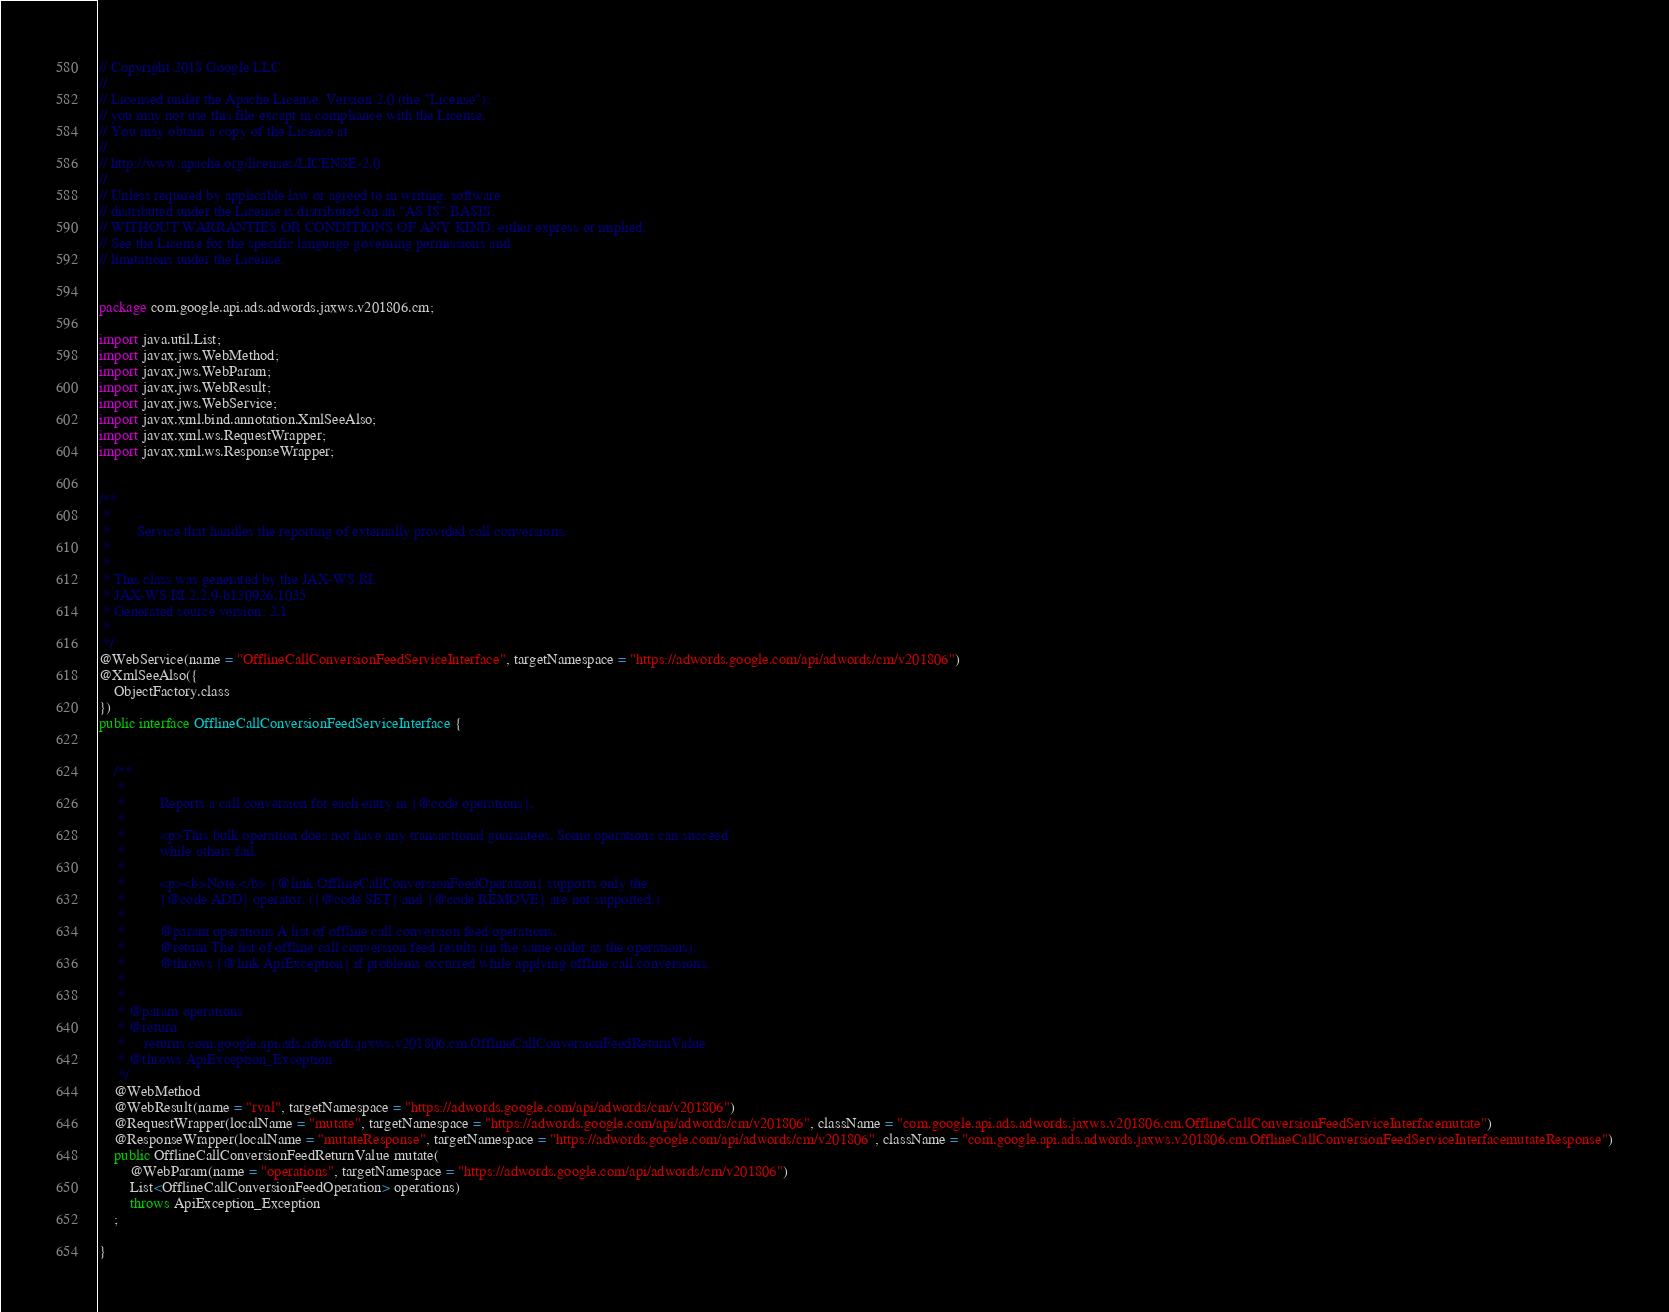<code> <loc_0><loc_0><loc_500><loc_500><_Java_>// Copyright 2018 Google LLC
//
// Licensed under the Apache License, Version 2.0 (the "License");
// you may not use this file except in compliance with the License.
// You may obtain a copy of the License at
//
// http://www.apache.org/licenses/LICENSE-2.0
//
// Unless required by applicable law or agreed to in writing, software
// distributed under the License is distributed on an "AS IS" BASIS,
// WITHOUT WARRANTIES OR CONDITIONS OF ANY KIND, either express or implied.
// See the License for the specific language governing permissions and
// limitations under the License.


package com.google.api.ads.adwords.jaxws.v201806.cm;

import java.util.List;
import javax.jws.WebMethod;
import javax.jws.WebParam;
import javax.jws.WebResult;
import javax.jws.WebService;
import javax.xml.bind.annotation.XmlSeeAlso;
import javax.xml.ws.RequestWrapper;
import javax.xml.ws.ResponseWrapper;


/**
 * 
 *       Service that handles the reporting of externally provided call conversions.
 *     
 * 
 * This class was generated by the JAX-WS RI.
 * JAX-WS RI 2.2.9-b130926.1035
 * Generated source version: 2.1
 * 
 */
@WebService(name = "OfflineCallConversionFeedServiceInterface", targetNamespace = "https://adwords.google.com/api/adwords/cm/v201806")
@XmlSeeAlso({
    ObjectFactory.class
})
public interface OfflineCallConversionFeedServiceInterface {


    /**
     * 
     *         Reports a call conversion for each entry in {@code operations}.
     *         
     *         <p>This bulk operation does not have any transactional guarantees. Some operations can succeed
     *         while others fail.
     *         
     *         <p><b>Note:</b> {@link OfflineCallConversionFeedOperation} supports only the
     *         {@code ADD} operator. ({@code SET} and {@code REMOVE} are not supported.)
     *         
     *         @param operations A list of offline call conversion feed operations.
     *         @return The list of offline call conversion feed results (in the same order as the operations).
     *         @throws {@link ApiException} if problems occurred while applying offline call conversions.
     *       
     * 
     * @param operations
     * @return
     *     returns com.google.api.ads.adwords.jaxws.v201806.cm.OfflineCallConversionFeedReturnValue
     * @throws ApiException_Exception
     */
    @WebMethod
    @WebResult(name = "rval", targetNamespace = "https://adwords.google.com/api/adwords/cm/v201806")
    @RequestWrapper(localName = "mutate", targetNamespace = "https://adwords.google.com/api/adwords/cm/v201806", className = "com.google.api.ads.adwords.jaxws.v201806.cm.OfflineCallConversionFeedServiceInterfacemutate")
    @ResponseWrapper(localName = "mutateResponse", targetNamespace = "https://adwords.google.com/api/adwords/cm/v201806", className = "com.google.api.ads.adwords.jaxws.v201806.cm.OfflineCallConversionFeedServiceInterfacemutateResponse")
    public OfflineCallConversionFeedReturnValue mutate(
        @WebParam(name = "operations", targetNamespace = "https://adwords.google.com/api/adwords/cm/v201806")
        List<OfflineCallConversionFeedOperation> operations)
        throws ApiException_Exception
    ;

}
</code> 